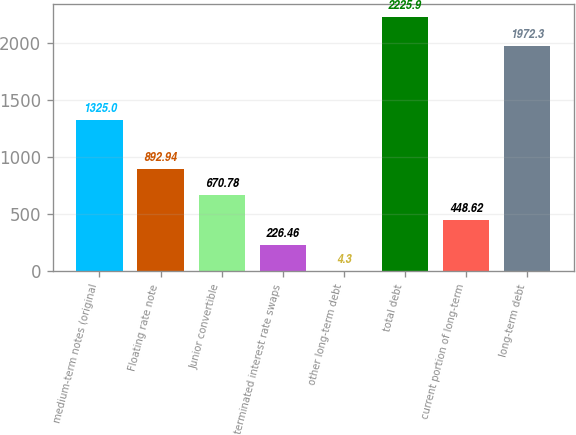Convert chart to OTSL. <chart><loc_0><loc_0><loc_500><loc_500><bar_chart><fcel>medium-term notes (original<fcel>Floating rate note<fcel>Junior convertible<fcel>terminated interest rate swaps<fcel>other long-term debt<fcel>total debt<fcel>current portion of long-term<fcel>long-term debt<nl><fcel>1325<fcel>892.94<fcel>670.78<fcel>226.46<fcel>4.3<fcel>2225.9<fcel>448.62<fcel>1972.3<nl></chart> 